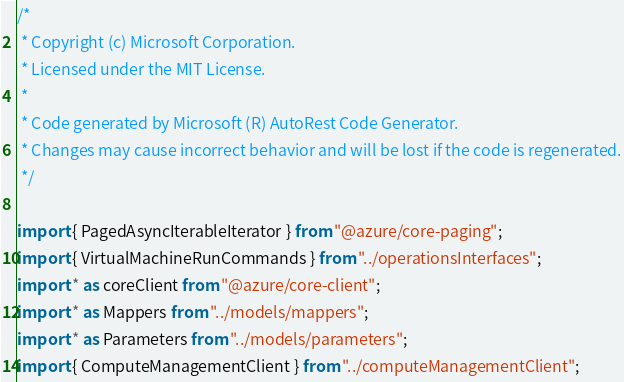<code> <loc_0><loc_0><loc_500><loc_500><_TypeScript_>/*
 * Copyright (c) Microsoft Corporation.
 * Licensed under the MIT License.
 *
 * Code generated by Microsoft (R) AutoRest Code Generator.
 * Changes may cause incorrect behavior and will be lost if the code is regenerated.
 */

import { PagedAsyncIterableIterator } from "@azure/core-paging";
import { VirtualMachineRunCommands } from "../operationsInterfaces";
import * as coreClient from "@azure/core-client";
import * as Mappers from "../models/mappers";
import * as Parameters from "../models/parameters";
import { ComputeManagementClient } from "../computeManagementClient";</code> 